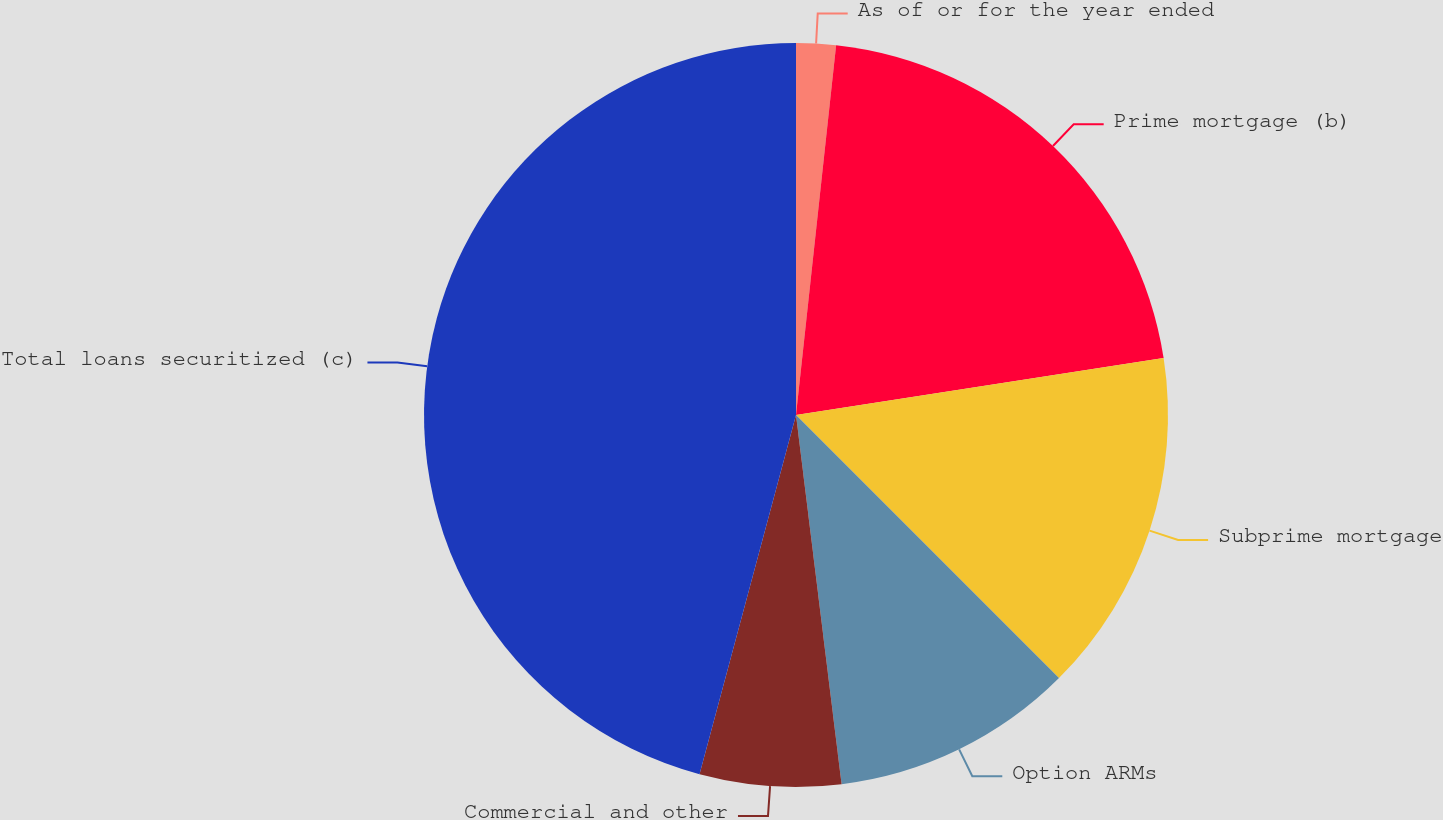Convert chart. <chart><loc_0><loc_0><loc_500><loc_500><pie_chart><fcel>As of or for the year ended<fcel>Prime mortgage (b)<fcel>Subprime mortgage<fcel>Option ARMs<fcel>Commercial and other<fcel>Total loans securitized (c)<nl><fcel>1.72%<fcel>20.83%<fcel>14.95%<fcel>10.54%<fcel>6.13%<fcel>45.82%<nl></chart> 